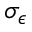<formula> <loc_0><loc_0><loc_500><loc_500>\sigma _ { \epsilon }</formula> 